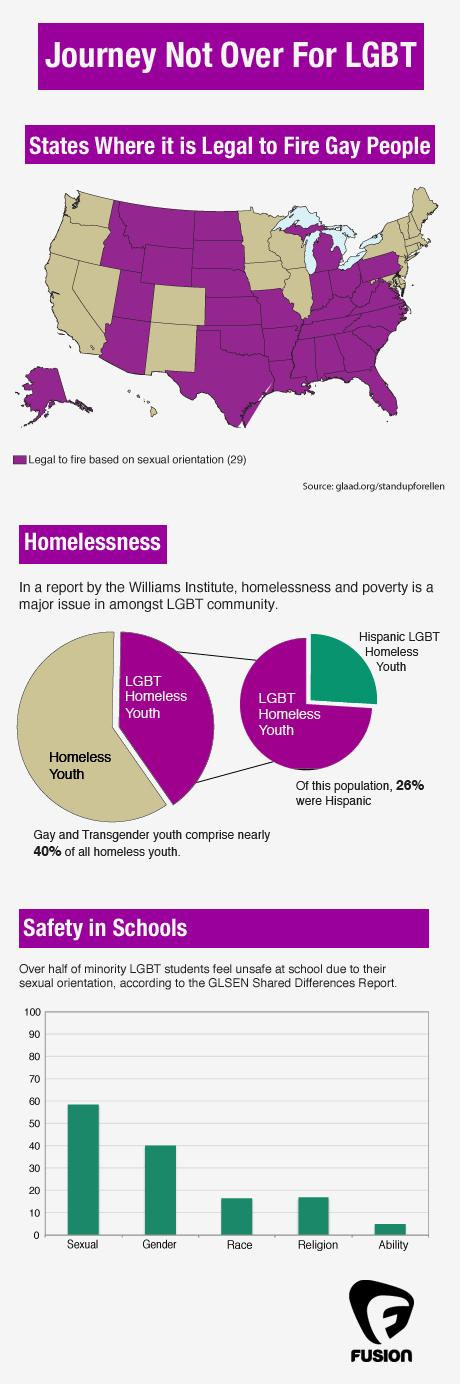Specify some key components in this picture. It is illegal in 21 states to fire someone based on their sexual orientation, specifically targeting gay individuals. The second highest reason for students to feel insecure is their gender. According to data, 74% of LGBT homeless youth do not belong to the Hispanic community. 